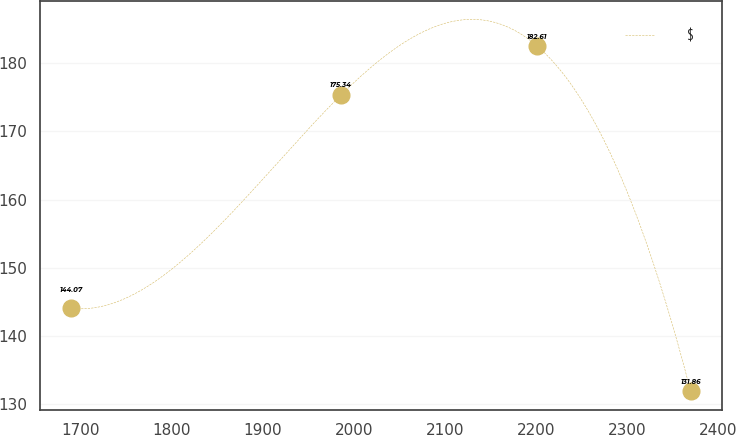<chart> <loc_0><loc_0><loc_500><loc_500><line_chart><ecel><fcel>$<nl><fcel>1690.27<fcel>144.07<nl><fcel>1986<fcel>175.34<nl><fcel>2200.46<fcel>182.61<nl><fcel>2369.48<fcel>131.86<nl></chart> 